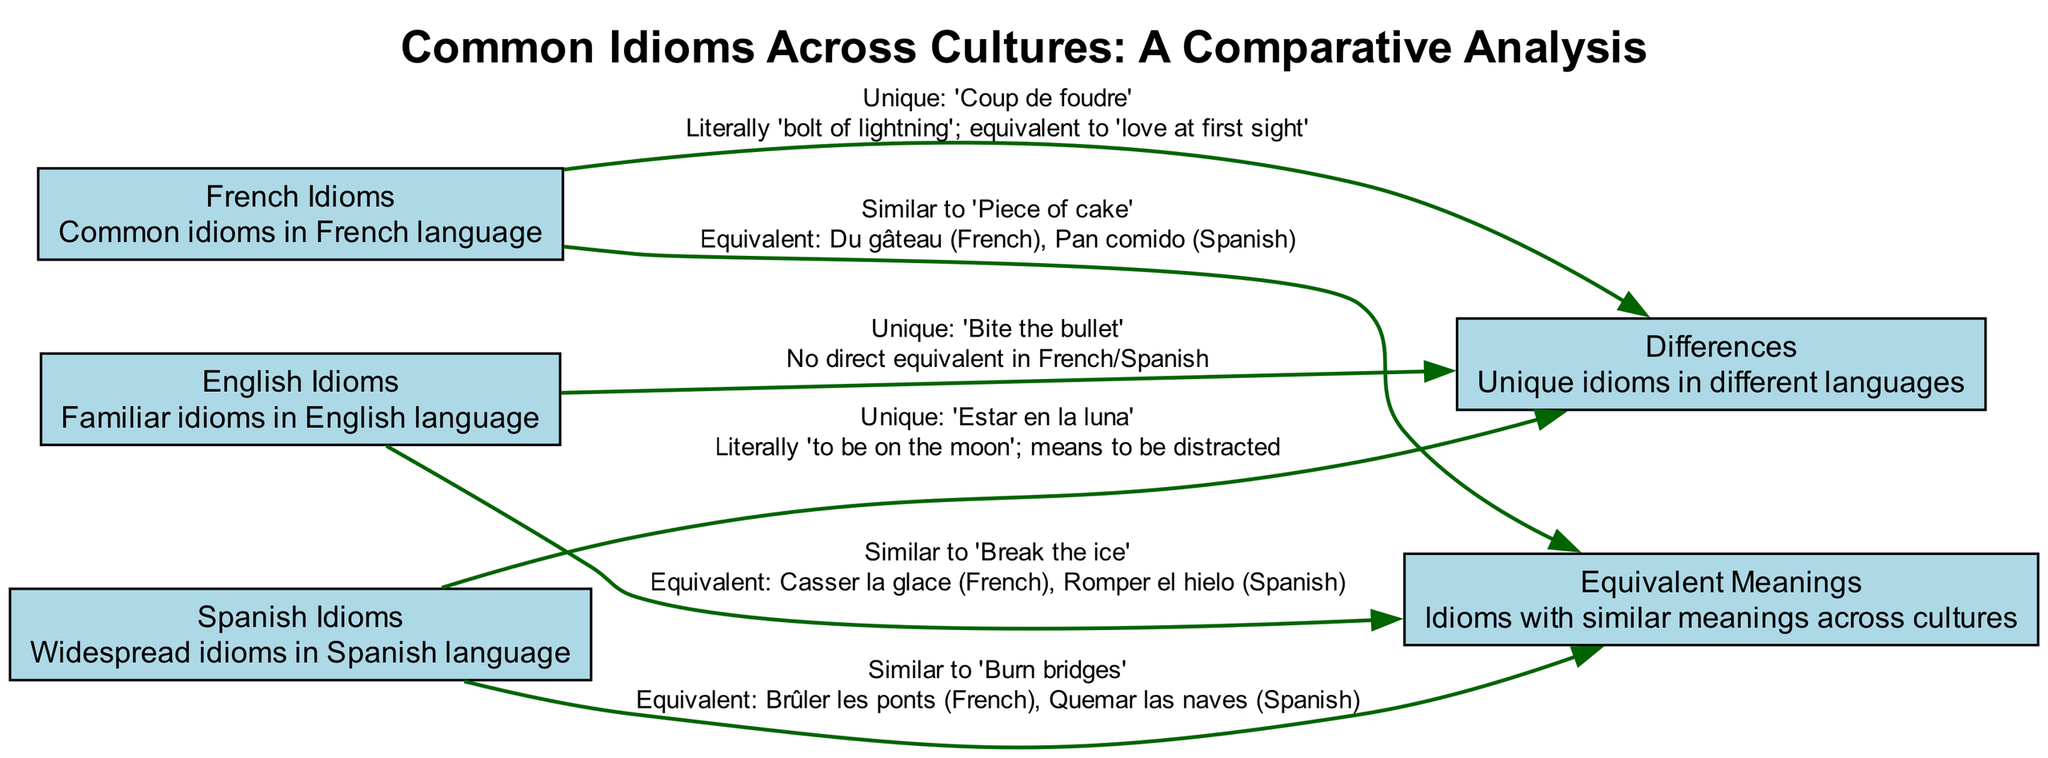What are the three languages represented in the idioms section? The diagram includes nodes for English Idioms, French Idioms, and Spanish Idioms, which represent the three languages depicted.
Answer: English, French, Spanish How many unique idioms are there in the diagram? The edges leading to the "Differences" node reveal three unique idioms: "Bite the bullet," "Coup de foudre," and "Estar en la luna." Therefore, there are three unique idioms.
Answer: 3 What is the idiom similar to "Burn bridges" in French? From the edge leading from Spanish Idioms to Equivalent Meanings, we learn that "Brûler les ponts" is the French equivalent, which indicates it directly corresponds to "Burn bridges."
Answer: Brûler les ponts How many idioms are related to the "Equivalent Meanings" node? Three edges connect English, French, and Spanish idioms to the Equivalent Meanings node, indicating that there are three idioms related to it.
Answer: 3 Which English idiom is considered unique? The edge from English Idioms to Differences specifies "Bite the bullet" as a unique idiom with no direct equivalent in French or Spanish, confirming its uniqueness.
Answer: Bite the bullet What idiom translates to "love at first sight" in French? The edge connecting French idioms to the Differences node specifies that "Coup de foudre" literally means 'bolt of lightning' and is equivalent to 'love at first sight.'
Answer: Coup de foudre Which idiom has the equivalent "Pan comido" in Spanish? The connection from French Idioms back to Equivalent Meanings specifies that "Du gâteau" is similar to "Piece of cake," which in Spanish is expressed as "Pan comido."
Answer: Pan comido How many connections are there leading to the "Differences" node? The diagram shows three unique idioms linking to the Differences node, with one from each language, confirming that there are three connections leading to this node.
Answer: 3 What does "Estar en la luna" mean in English? The edge connected to the "Differences" node describes "Estar en la luna" literally as "to be on the moon," meaning to be distracted in English.
Answer: to be distracted 